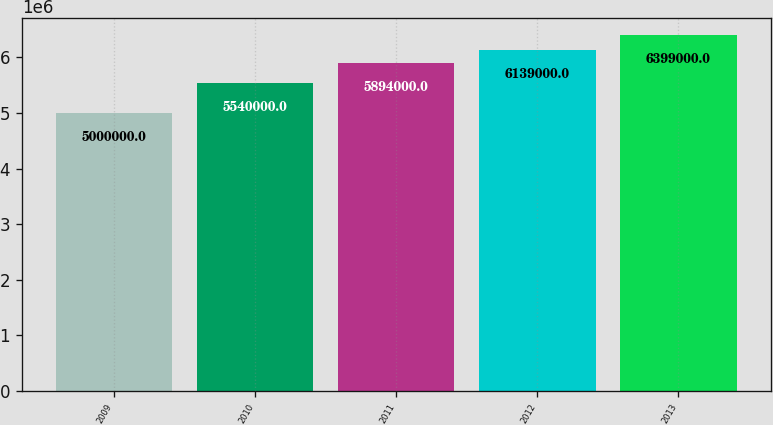Convert chart. <chart><loc_0><loc_0><loc_500><loc_500><bar_chart><fcel>2009<fcel>2010<fcel>2011<fcel>2012<fcel>2013<nl><fcel>5e+06<fcel>5.54e+06<fcel>5.894e+06<fcel>6.139e+06<fcel>6.399e+06<nl></chart> 